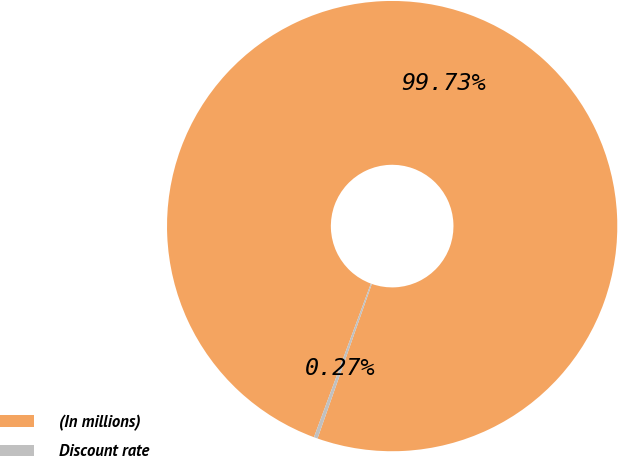<chart> <loc_0><loc_0><loc_500><loc_500><pie_chart><fcel>(In millions)<fcel>Discount rate<nl><fcel>99.73%<fcel>0.27%<nl></chart> 